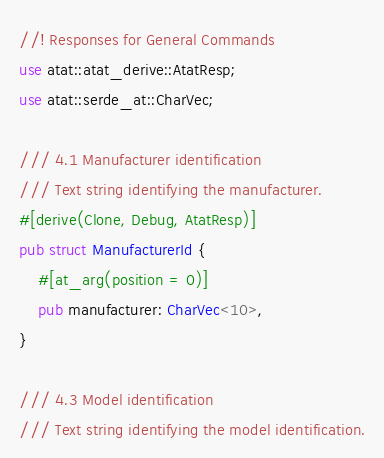<code> <loc_0><loc_0><loc_500><loc_500><_Rust_>//! Responses for General Commands
use atat::atat_derive::AtatResp;
use atat::serde_at::CharVec;

/// 4.1 Manufacturer identification
/// Text string identifying the manufacturer.
#[derive(Clone, Debug, AtatResp)]
pub struct ManufacturerId {
    #[at_arg(position = 0)]
    pub manufacturer: CharVec<10>,
}

/// 4.3 Model identification
/// Text string identifying the model identification.</code> 